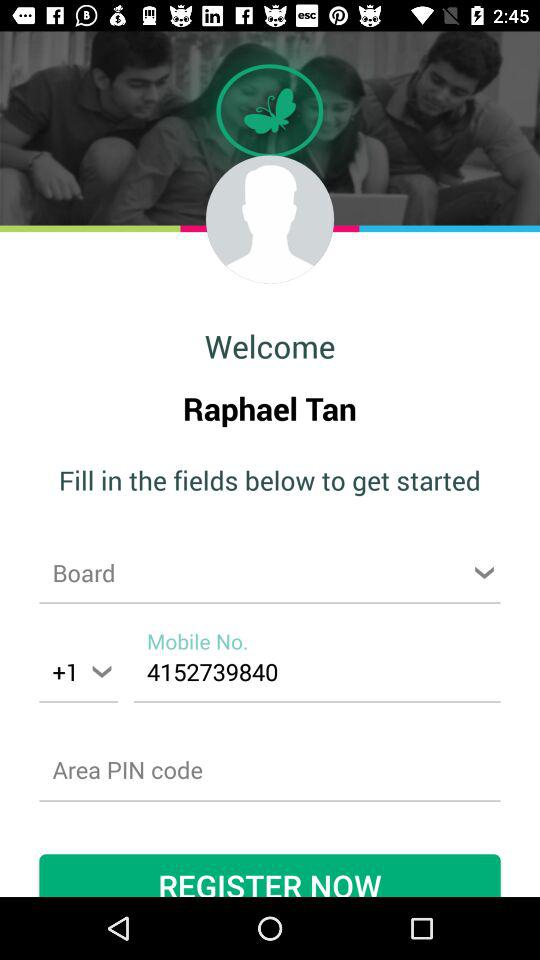What is the registration name? The registration name is Raphael Tan. 